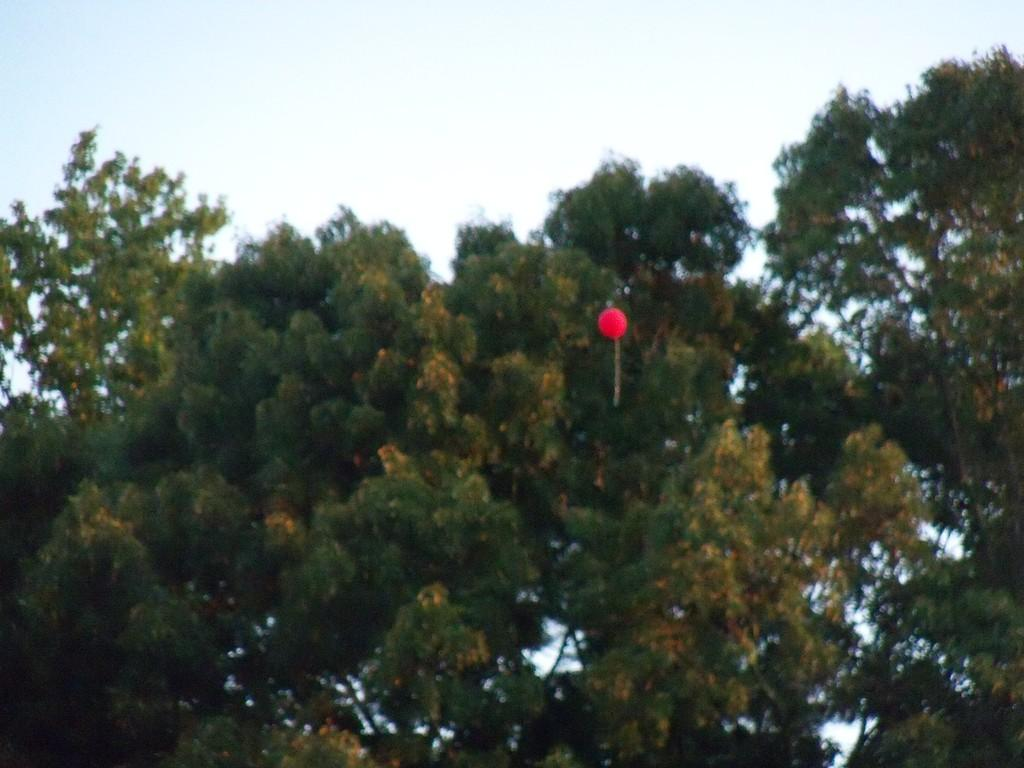What type of natural elements can be seen in the image? There are trees in the image. What color is the balloon in the image? The balloon in the image is red. What part of the natural environment is visible in the image? The sky is visible in the image. What type of organization is depicted in the image? There is no organization depicted in the image; it features trees, a red balloon, and the sky. Is there a beggar visible in the image? There is no beggar present in the image. 